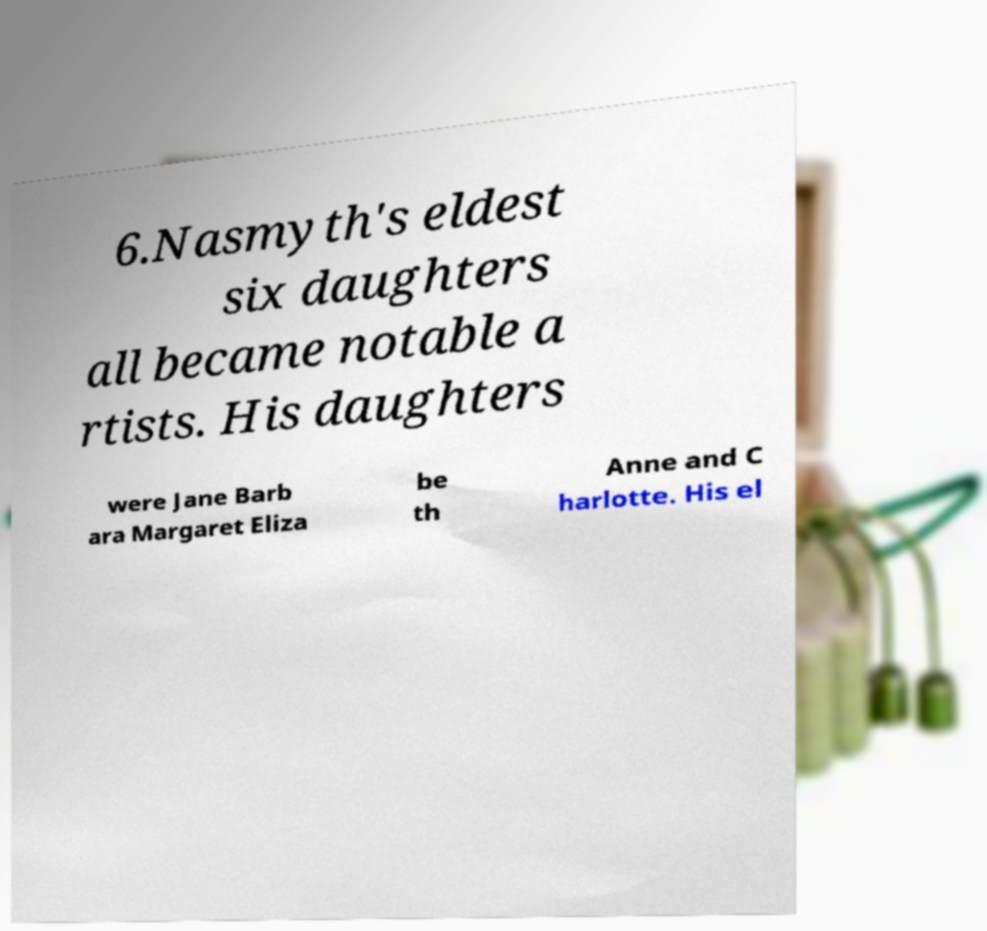There's text embedded in this image that I need extracted. Can you transcribe it verbatim? 6.Nasmyth's eldest six daughters all became notable a rtists. His daughters were Jane Barb ara Margaret Eliza be th Anne and C harlotte. His el 